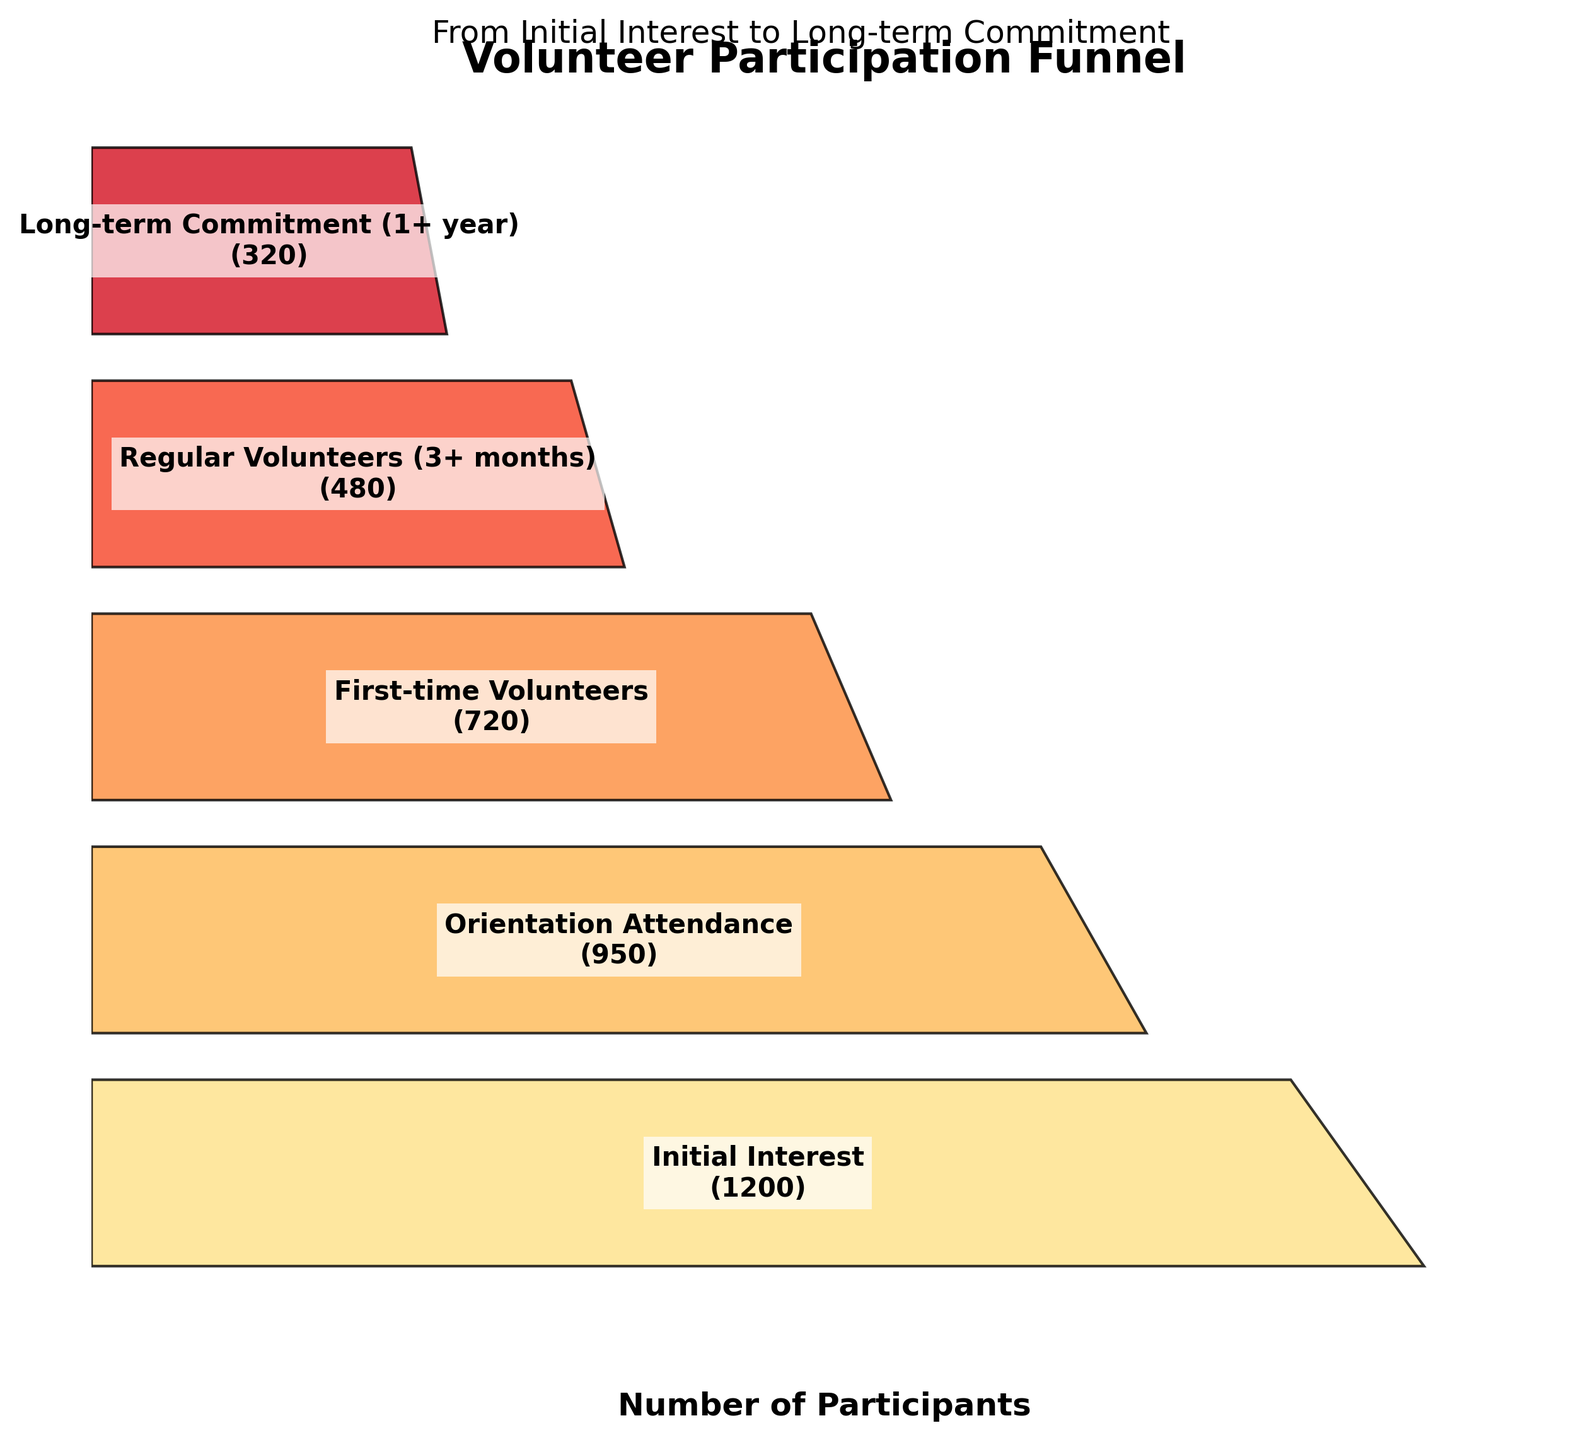What's the title of the figure? The title of the figure is displayed at the top and reads "Volunteer Participation Funnel."
Answer: Volunteer Participation Funnel How many stages are displayed in the funnel chart? The funnel chart shows 5 stages, each representing a step in the volunteer participation process.
Answer: 5 Which stage has the highest number of participants? The stage with the highest number of participants is "Initial Interest," which shows 1200 participants.
Answer: Initial Interest What is the difference in the number of participants between Orientation Attendance and First-time Volunteers stages? To find the difference, subtract the participants in the First-time Volunteers stage (720) from the participants in the Orientation Attendance stage (950): 950 - 720 = 230.
Answer: 230 How many participants reach the Long-term Commitment stage? The number of participants at the Long-term Commitment stage is shown on the funnel chart as 320.
Answer: 320 Which stage has the lowest number of participants? The stage with the lowest number of participants is "Long-term Commitment," with 320 participants.
Answer: Long-term Commitment How many more participants are at the Initial Interest stage than at the Regular Volunteers stage? To find out how many more participants are at the Initial Interest stage compared to the Regular Volunteers stage, subtract the participants in Regular Volunteers (480) from the participants in Initial Interest (1200): 1200 - 480 = 720.
Answer: 720 What is the average number of participants across all stages? To calculate the average, sum the number of participants across all stages and divide by the number of stages. Total participants: 1200 + 950 + 720 + 480 + 320 = 3670. Average: 3670 / 5 = 734.
Answer: 734 How many stages have more than 500 participants? The stages with more than 500 participants are Initial Interest (1200), Orientation Attendance (950), and First-time Volunteers (720), totaling three stages.
Answer: 3 